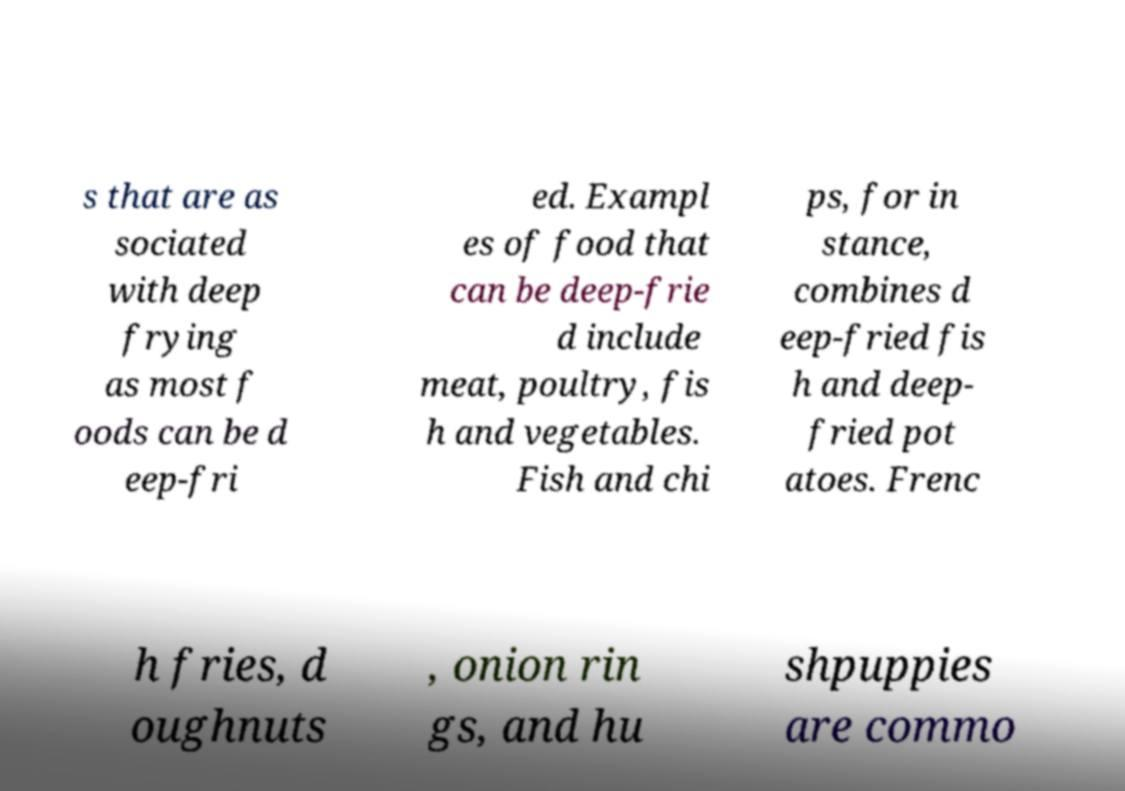What messages or text are displayed in this image? I need them in a readable, typed format. s that are as sociated with deep frying as most f oods can be d eep-fri ed. Exampl es of food that can be deep-frie d include meat, poultry, fis h and vegetables. Fish and chi ps, for in stance, combines d eep-fried fis h and deep- fried pot atoes. Frenc h fries, d oughnuts , onion rin gs, and hu shpuppies are commo 